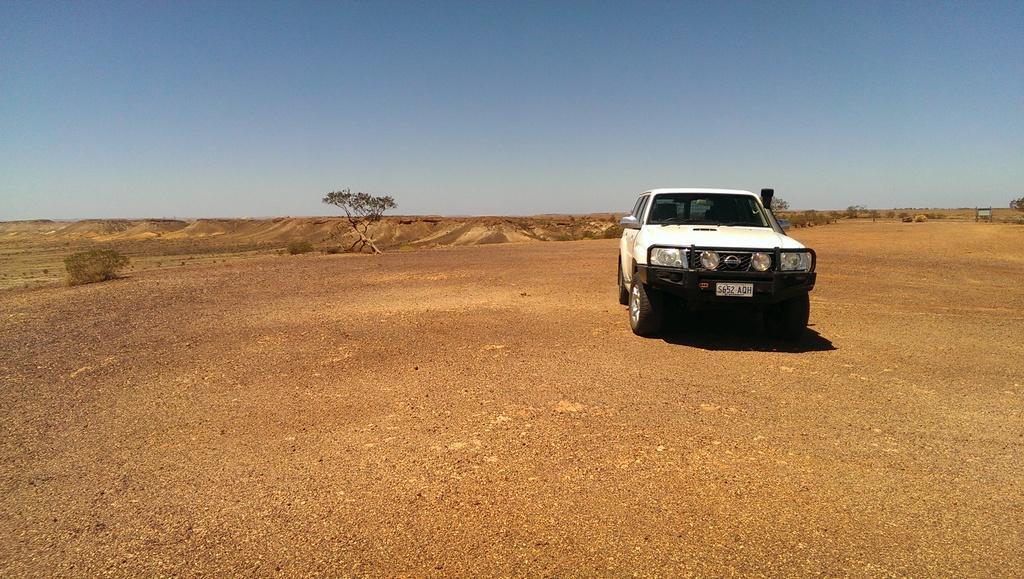Describe this image in one or two sentences. In this image we can see a car on the ground. On the car we can see a number plate. Behind the car we can see a tree and plants. At the top we can see the sky. 